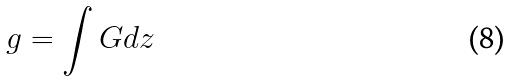<formula> <loc_0><loc_0><loc_500><loc_500>g = \int G d z</formula> 